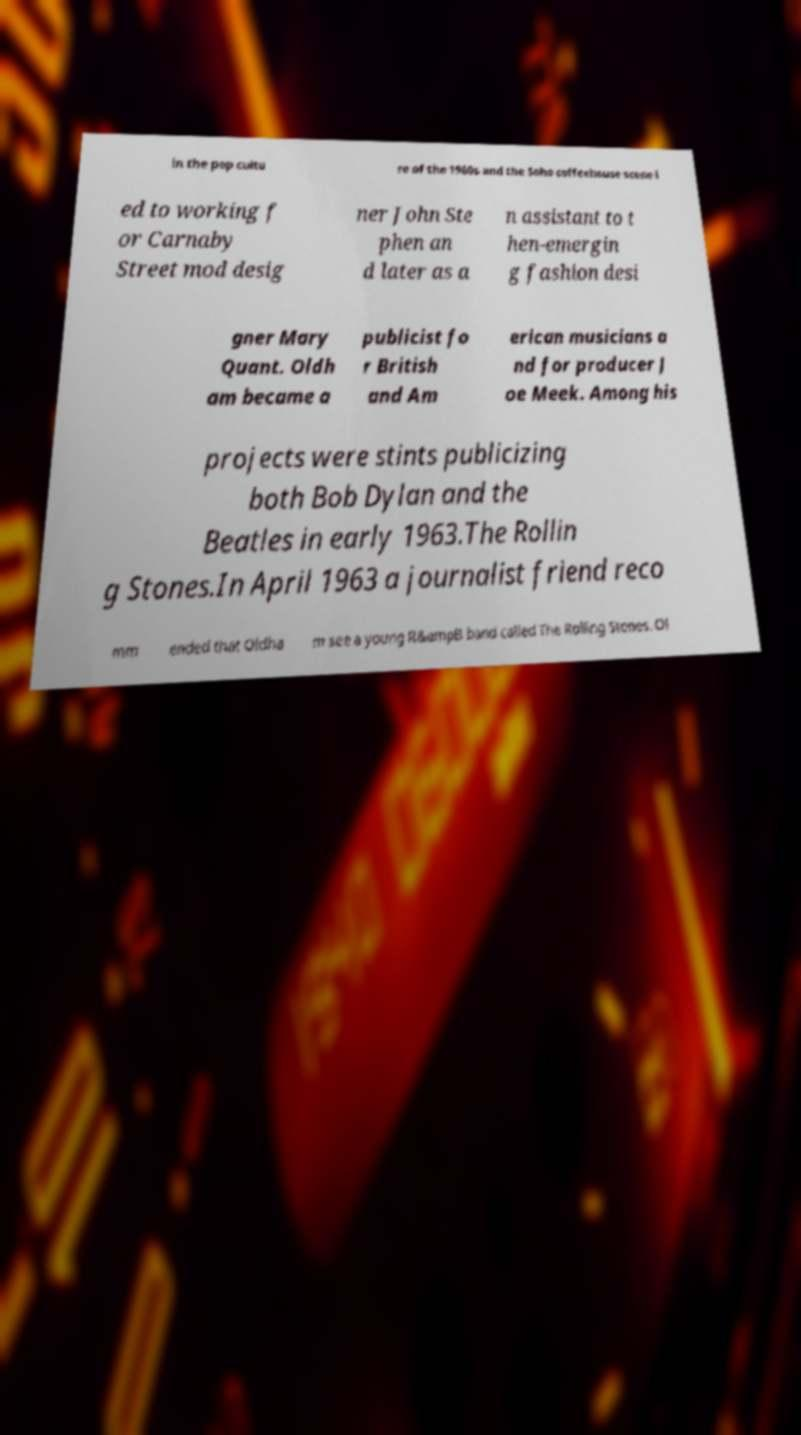For documentation purposes, I need the text within this image transcribed. Could you provide that? in the pop cultu re of the 1960s and the Soho coffeehouse scene l ed to working f or Carnaby Street mod desig ner John Ste phen an d later as a n assistant to t hen-emergin g fashion desi gner Mary Quant. Oldh am became a publicist fo r British and Am erican musicians a nd for producer J oe Meek. Among his projects were stints publicizing both Bob Dylan and the Beatles in early 1963.The Rollin g Stones.In April 1963 a journalist friend reco mm ended that Oldha m see a young R&ampB band called The Rolling Stones. Ol 